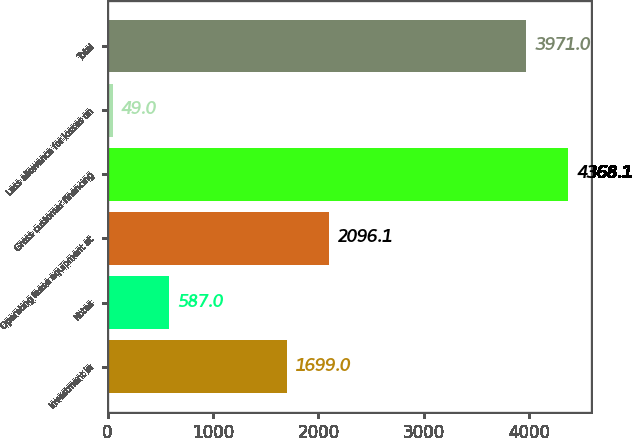Convert chart to OTSL. <chart><loc_0><loc_0><loc_500><loc_500><bar_chart><fcel>Investment in<fcel>Notes<fcel>Operating lease equipment at<fcel>Gross customer financing<fcel>Less allowance for losses on<fcel>Total<nl><fcel>1699<fcel>587<fcel>2096.1<fcel>4368.1<fcel>49<fcel>3971<nl></chart> 